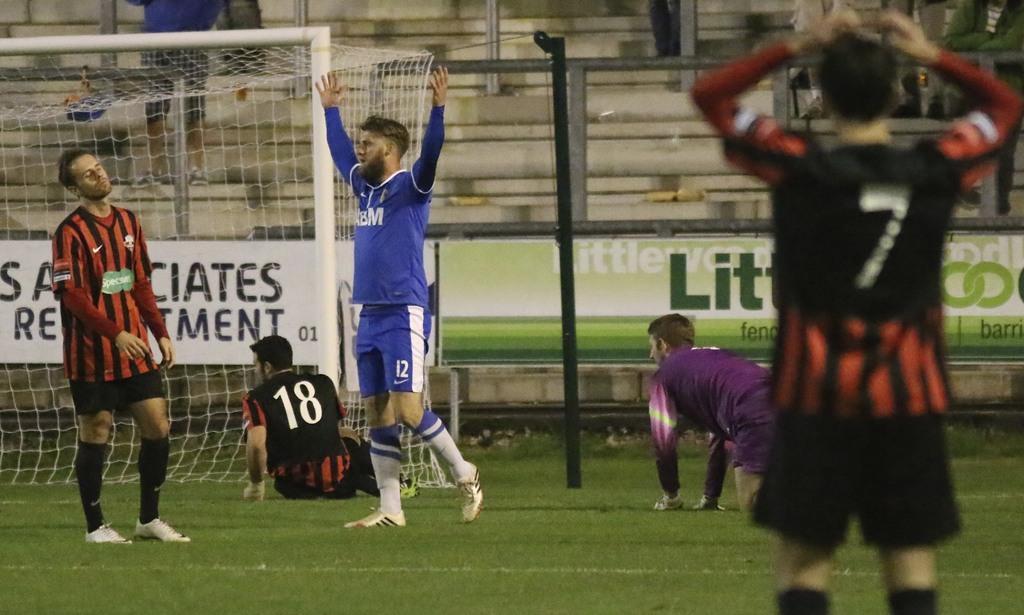Please provide a concise description of this image. In this image, we can see people wearing clothes. There is goal post on the left side of the image. There is a pole and board in the middle of the image. 